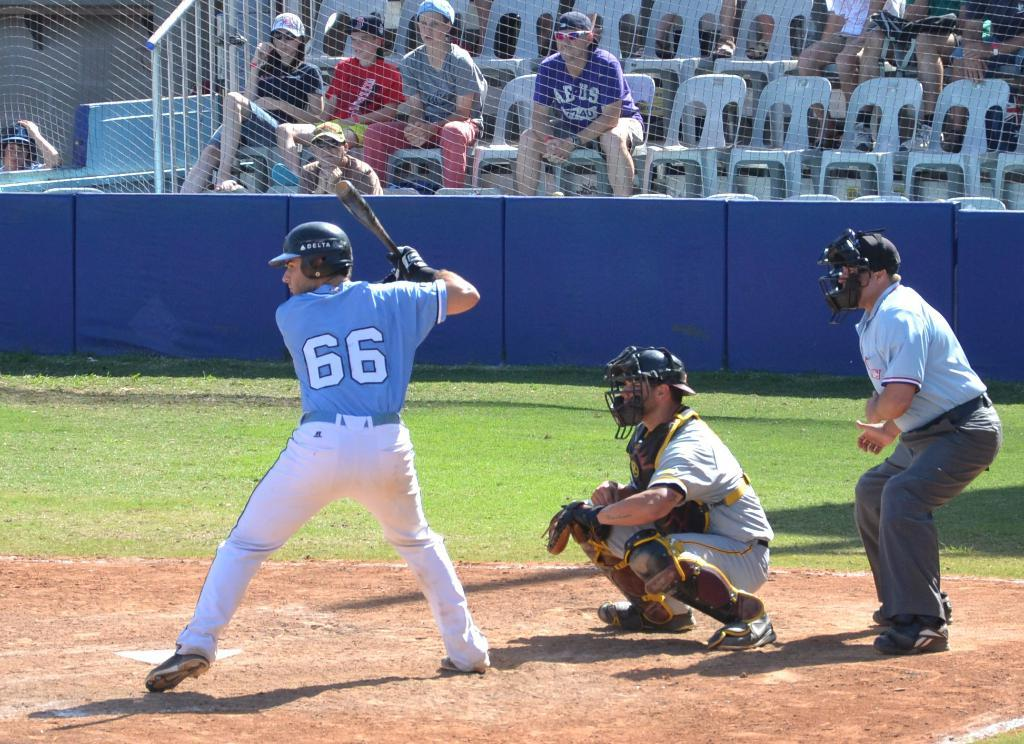Provide a one-sentence caption for the provided image. a baseball batter with the numbere 66 on the back of his jersey. 